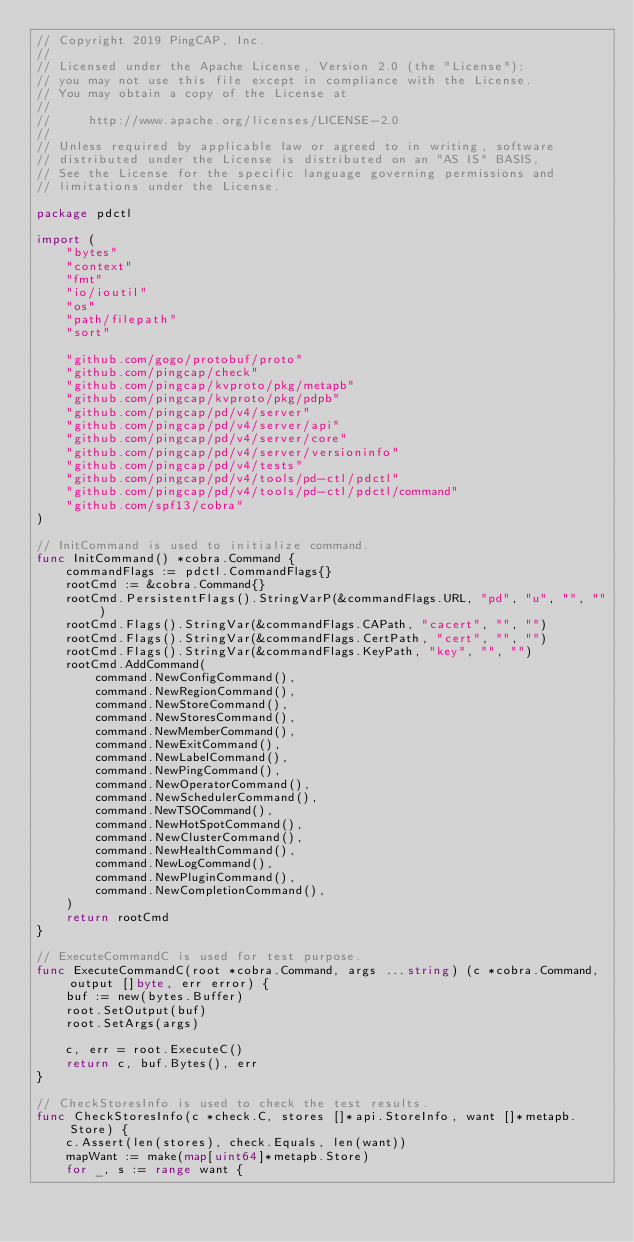<code> <loc_0><loc_0><loc_500><loc_500><_Go_>// Copyright 2019 PingCAP, Inc.
//
// Licensed under the Apache License, Version 2.0 (the "License");
// you may not use this file except in compliance with the License.
// You may obtain a copy of the License at
//
//     http://www.apache.org/licenses/LICENSE-2.0
//
// Unless required by applicable law or agreed to in writing, software
// distributed under the License is distributed on an "AS IS" BASIS,
// See the License for the specific language governing permissions and
// limitations under the License.

package pdctl

import (
	"bytes"
	"context"
	"fmt"
	"io/ioutil"
	"os"
	"path/filepath"
	"sort"

	"github.com/gogo/protobuf/proto"
	"github.com/pingcap/check"
	"github.com/pingcap/kvproto/pkg/metapb"
	"github.com/pingcap/kvproto/pkg/pdpb"
	"github.com/pingcap/pd/v4/server"
	"github.com/pingcap/pd/v4/server/api"
	"github.com/pingcap/pd/v4/server/core"
	"github.com/pingcap/pd/v4/server/versioninfo"
	"github.com/pingcap/pd/v4/tests"
	"github.com/pingcap/pd/v4/tools/pd-ctl/pdctl"
	"github.com/pingcap/pd/v4/tools/pd-ctl/pdctl/command"
	"github.com/spf13/cobra"
)

// InitCommand is used to initialize command.
func InitCommand() *cobra.Command {
	commandFlags := pdctl.CommandFlags{}
	rootCmd := &cobra.Command{}
	rootCmd.PersistentFlags().StringVarP(&commandFlags.URL, "pd", "u", "", "")
	rootCmd.Flags().StringVar(&commandFlags.CAPath, "cacert", "", "")
	rootCmd.Flags().StringVar(&commandFlags.CertPath, "cert", "", "")
	rootCmd.Flags().StringVar(&commandFlags.KeyPath, "key", "", "")
	rootCmd.AddCommand(
		command.NewConfigCommand(),
		command.NewRegionCommand(),
		command.NewStoreCommand(),
		command.NewStoresCommand(),
		command.NewMemberCommand(),
		command.NewExitCommand(),
		command.NewLabelCommand(),
		command.NewPingCommand(),
		command.NewOperatorCommand(),
		command.NewSchedulerCommand(),
		command.NewTSOCommand(),
		command.NewHotSpotCommand(),
		command.NewClusterCommand(),
		command.NewHealthCommand(),
		command.NewLogCommand(),
		command.NewPluginCommand(),
		command.NewCompletionCommand(),
	)
	return rootCmd
}

// ExecuteCommandC is used for test purpose.
func ExecuteCommandC(root *cobra.Command, args ...string) (c *cobra.Command, output []byte, err error) {
	buf := new(bytes.Buffer)
	root.SetOutput(buf)
	root.SetArgs(args)

	c, err = root.ExecuteC()
	return c, buf.Bytes(), err
}

// CheckStoresInfo is used to check the test results.
func CheckStoresInfo(c *check.C, stores []*api.StoreInfo, want []*metapb.Store) {
	c.Assert(len(stores), check.Equals, len(want))
	mapWant := make(map[uint64]*metapb.Store)
	for _, s := range want {</code> 